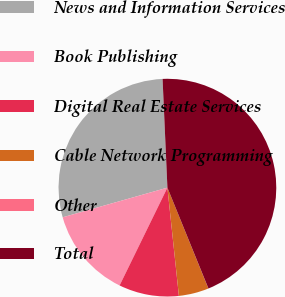<chart> <loc_0><loc_0><loc_500><loc_500><pie_chart><fcel>News and Information Services<fcel>Book Publishing<fcel>Digital Real Estate Services<fcel>Cable Network Programming<fcel>Other<fcel>Total<nl><fcel>28.68%<fcel>13.37%<fcel>8.92%<fcel>4.46%<fcel>0.01%<fcel>44.55%<nl></chart> 